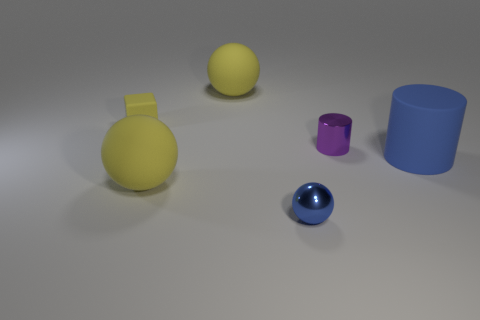Is the number of yellow cubes less than the number of small metal objects?
Your answer should be very brief. Yes. There is a tiny rubber cube left of the matte ball that is behind the tiny metal cylinder; what number of large balls are left of it?
Your response must be concise. 0. What is the size of the metallic ball to the left of the purple cylinder?
Offer a very short reply. Small. Do the tiny metallic thing behind the blue matte object and the large blue rubber thing have the same shape?
Provide a short and direct response. Yes. There is a large object that is the same shape as the tiny purple shiny thing; what is its material?
Provide a succinct answer. Rubber. Is there a red sphere?
Ensure brevity in your answer.  No. There is a blue thing behind the small metal object that is in front of the matte object that is on the right side of the blue metal ball; what is its material?
Your response must be concise. Rubber. Is the shape of the small purple metallic object the same as the large thing that is right of the purple metal cylinder?
Provide a short and direct response. Yes. What number of large blue things have the same shape as the small yellow matte object?
Your response must be concise. 0. There is a purple object; what shape is it?
Provide a succinct answer. Cylinder. 